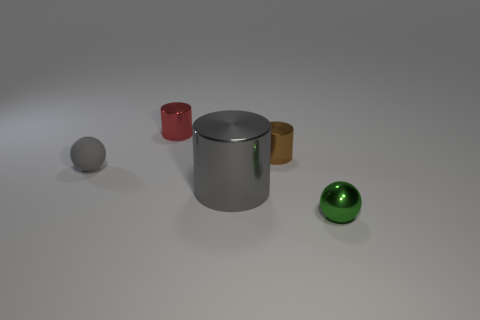Subtract all large gray cylinders. How many cylinders are left? 2 Add 1 big purple cubes. How many objects exist? 6 Subtract all gray cylinders. How many cylinders are left? 2 Subtract 2 balls. How many balls are left? 0 Subtract 0 cyan cubes. How many objects are left? 5 Subtract all cylinders. How many objects are left? 2 Subtract all red spheres. Subtract all cyan blocks. How many spheres are left? 2 Subtract all large metal objects. Subtract all tiny brown cylinders. How many objects are left? 3 Add 1 tiny gray objects. How many tiny gray objects are left? 2 Add 3 large gray cylinders. How many large gray cylinders exist? 4 